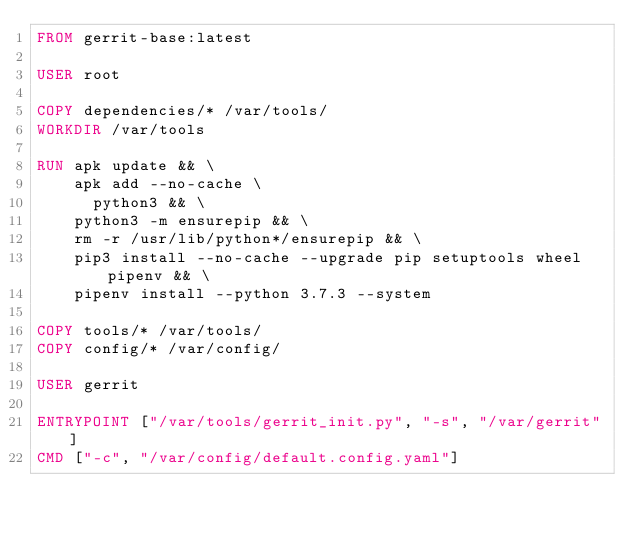Convert code to text. <code><loc_0><loc_0><loc_500><loc_500><_Dockerfile_>FROM gerrit-base:latest

USER root

COPY dependencies/* /var/tools/
WORKDIR /var/tools

RUN apk update && \
    apk add --no-cache \
      python3 && \
    python3 -m ensurepip && \
    rm -r /usr/lib/python*/ensurepip && \
    pip3 install --no-cache --upgrade pip setuptools wheel pipenv && \
    pipenv install --python 3.7.3 --system

COPY tools/* /var/tools/
COPY config/* /var/config/

USER gerrit

ENTRYPOINT ["/var/tools/gerrit_init.py", "-s", "/var/gerrit"]
CMD ["-c", "/var/config/default.config.yaml"]
</code> 